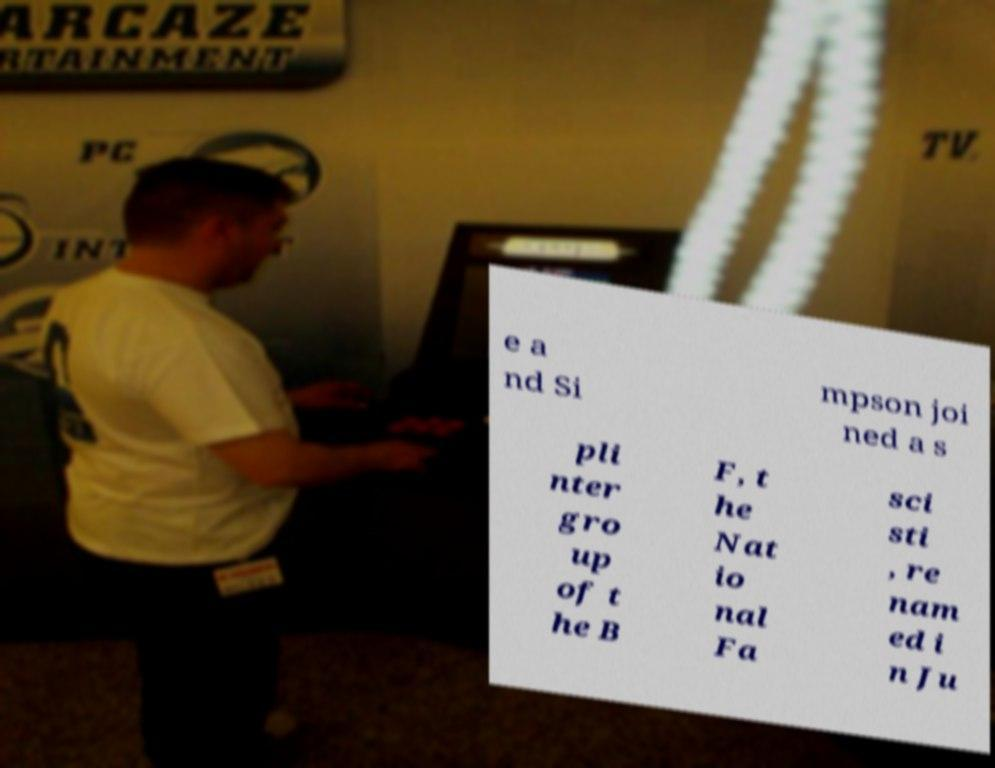What messages or text are displayed in this image? I need them in a readable, typed format. e a nd Si mpson joi ned a s pli nter gro up of t he B F, t he Nat io nal Fa sci sti , re nam ed i n Ju 